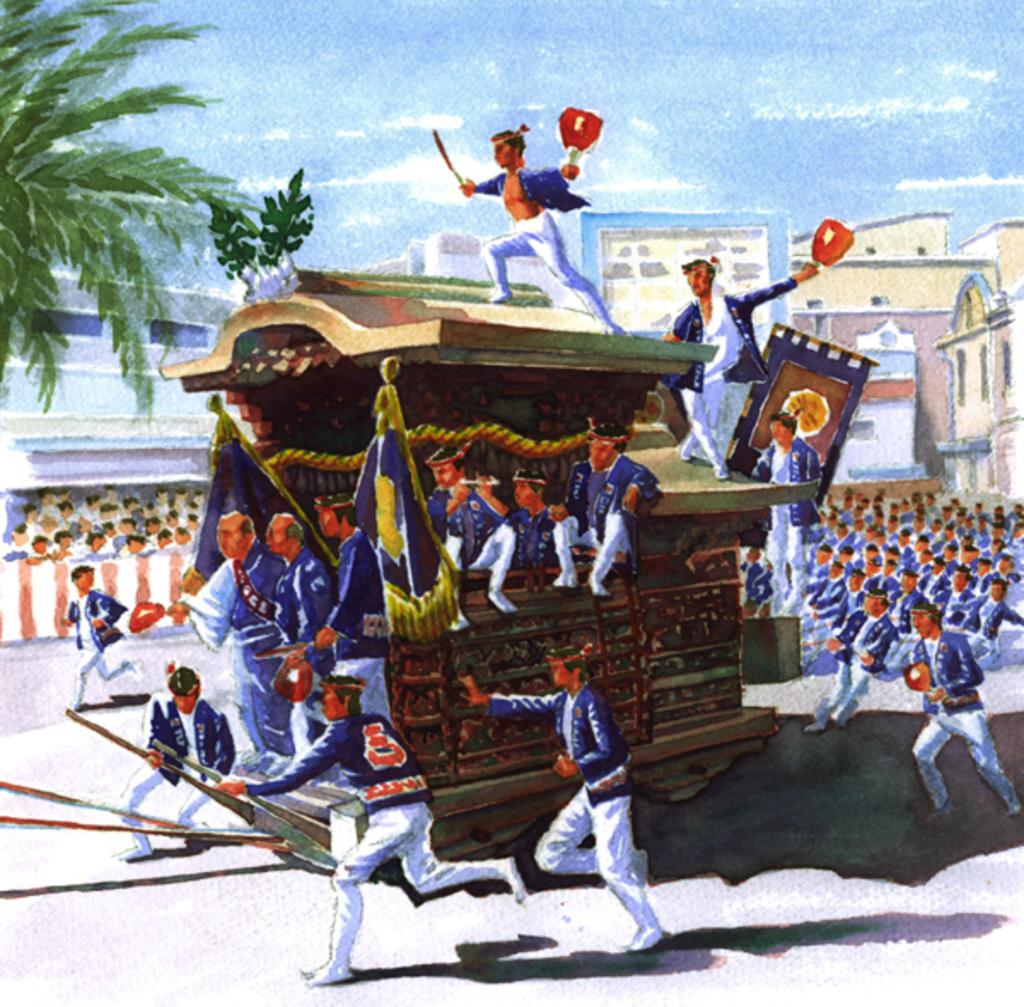What is the main subject of the image? There is a painting in the image. What is happening in the painting? The painting depicts people in a cart. What can be seen on the left side of the image? There is a tree on the left side of the image. What is visible in the background of the image? There is a building and the sky in the background of the image. What type of club is being used by the people in the painting? There is no club visible in the painting; it depicts people in a cart. What design elements can be seen in the motion of the cart? The painting is static, and there is no motion depicted in the image. 